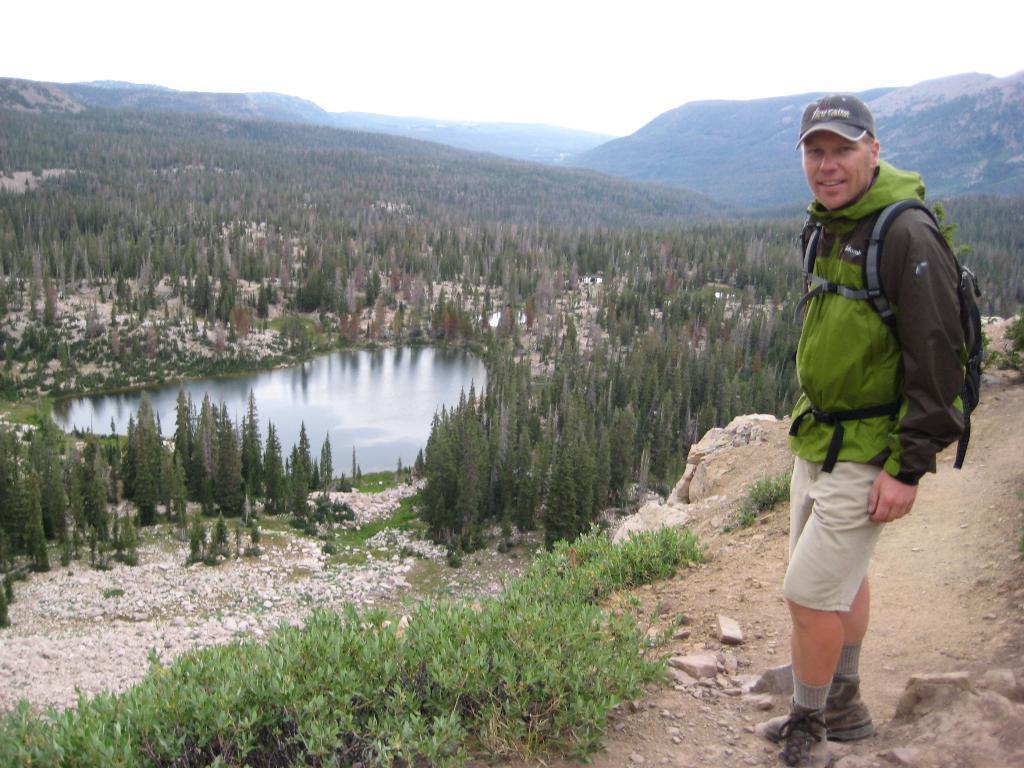Please provide a concise description of this image. in this image in the right a person is standing. He is carrying a bag , wearing a jacket. In the back there are trees pool. It is looking like a hilly area. 